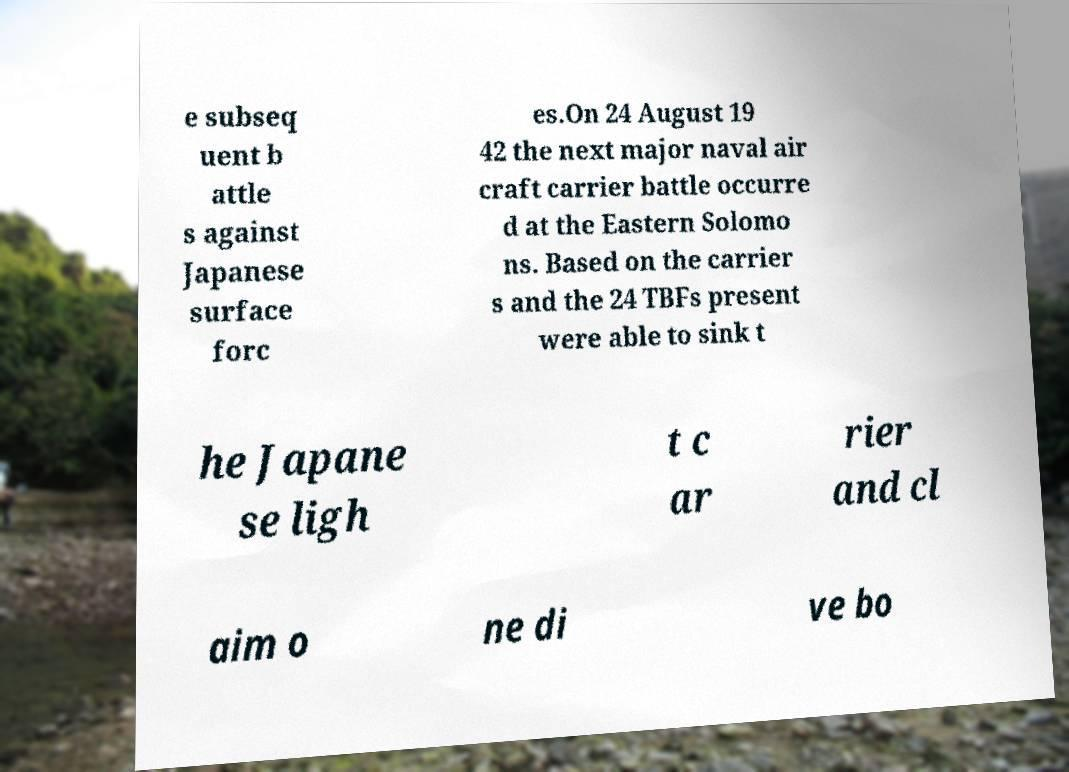Please identify and transcribe the text found in this image. e subseq uent b attle s against Japanese surface forc es.On 24 August 19 42 the next major naval air craft carrier battle occurre d at the Eastern Solomo ns. Based on the carrier s and the 24 TBFs present were able to sink t he Japane se ligh t c ar rier and cl aim o ne di ve bo 